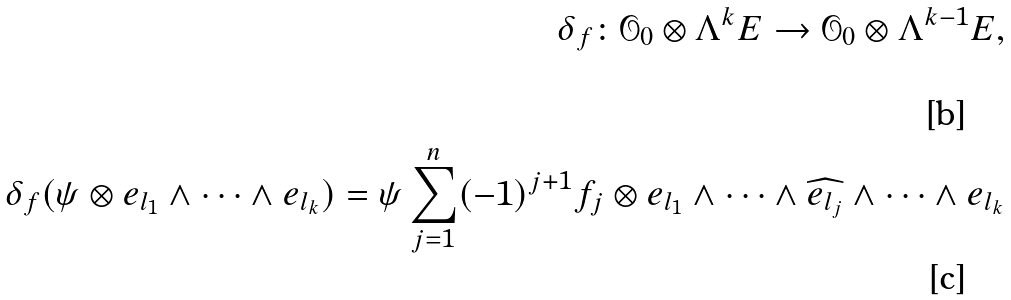Convert formula to latex. <formula><loc_0><loc_0><loc_500><loc_500>\delta _ { f } \colon \mathcal { O } _ { 0 } \otimes \Lambda ^ { k } E \rightarrow \mathcal { O } _ { 0 } \otimes \Lambda ^ { k - 1 } E , \\ \delta _ { f } ( \psi \otimes e _ { l _ { 1 } } \wedge \dots \wedge e _ { l _ { k } } ) = \psi \sum _ { j = 1 } ^ { n } ( - 1 ) ^ { j + 1 } f _ { j } \otimes e _ { l _ { 1 } } \wedge \dots \wedge \widehat { e _ { l _ { j } } } \wedge \dots \wedge e _ { l _ { k } }</formula> 